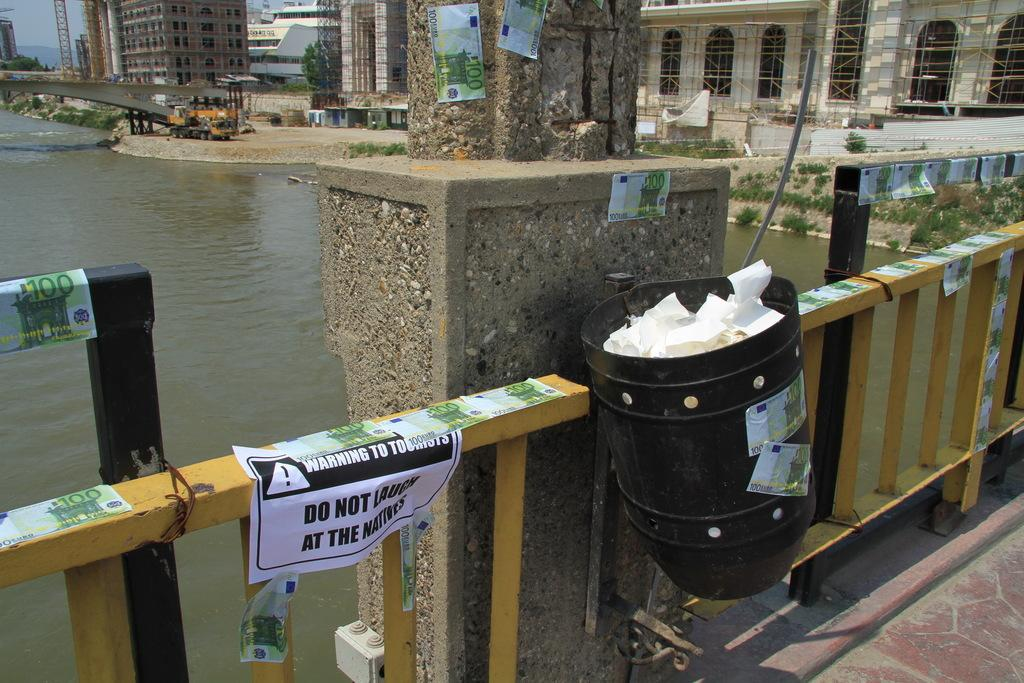<image>
Render a clear and concise summary of the photo. A view of a bridge over water with a warning sign taped to it 